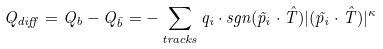<formula> <loc_0><loc_0><loc_500><loc_500>Q _ { d i f f } = Q _ { b } - Q _ { \bar { b } } = - \sum _ { t r a c k s } q _ { i } \cdot s g n ( \vec { p } _ { i } \cdot \hat { T } ) | ( \vec { p } _ { i } \cdot \hat { T } ) | ^ { \kappa }</formula> 